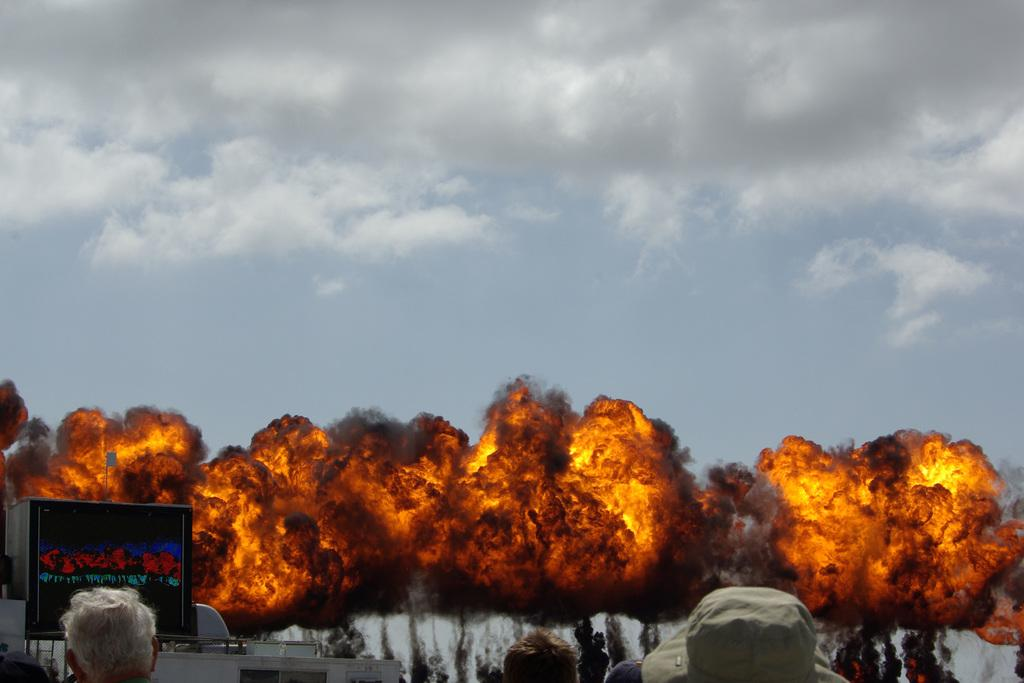Who or what is present in the image? There are people in the image. What can be seen on a wall or surface in the image? There is a poster in the image. What type of object might be used for transportation in the image? It appears there is a vehicle in the image. What is happening in the foreground area of the image? There is fire in the foreground area of the image. What is visible in the background area of the image? The sky is visible in the background area of the image. What type of skin condition can be seen on the people in the image? There is no indication of any skin condition on the people in the image. What type of pan is being used to cook the food in the image? There is no pan or food visible in the image. 